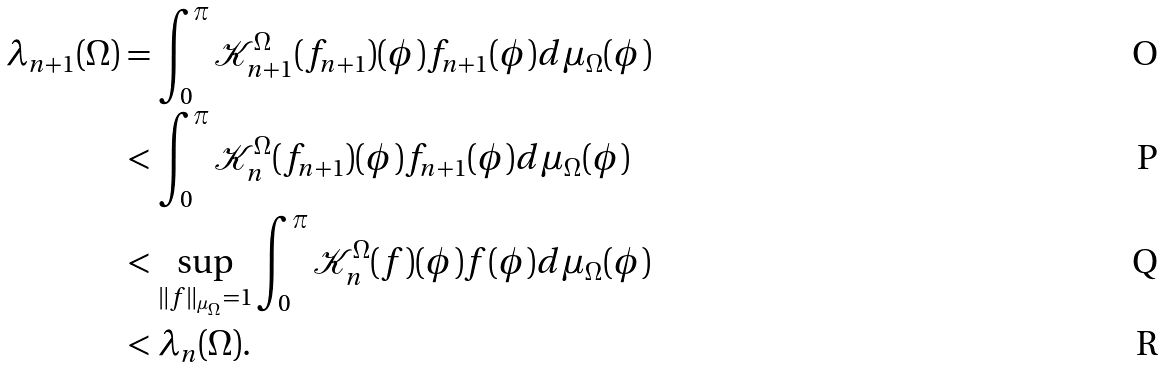<formula> <loc_0><loc_0><loc_500><loc_500>\lambda _ { n + 1 } ( \Omega ) & = \int _ { 0 } ^ { \pi } \mathcal { K } _ { n + 1 } ^ { \Omega } ( f _ { n + 1 } ) ( \phi ) f _ { n + 1 } ( \phi ) d \mu _ { \Omega } ( \phi ) \\ & < \int _ { 0 } ^ { \pi } \mathcal { K } _ { n } ^ { \Omega } ( f _ { n + 1 } ) ( \phi ) f _ { n + 1 } ( \phi ) d \mu _ { \Omega } ( \phi ) \\ & < \sup _ { \| f \| _ { \mu _ { \Omega } } = 1 } \int _ { 0 } ^ { \pi } \mathcal { K } _ { n } ^ { \Omega } ( f ) ( \phi ) f ( \phi ) d \mu _ { \Omega } ( \phi ) \\ & < \lambda _ { n } ( \Omega ) .</formula> 